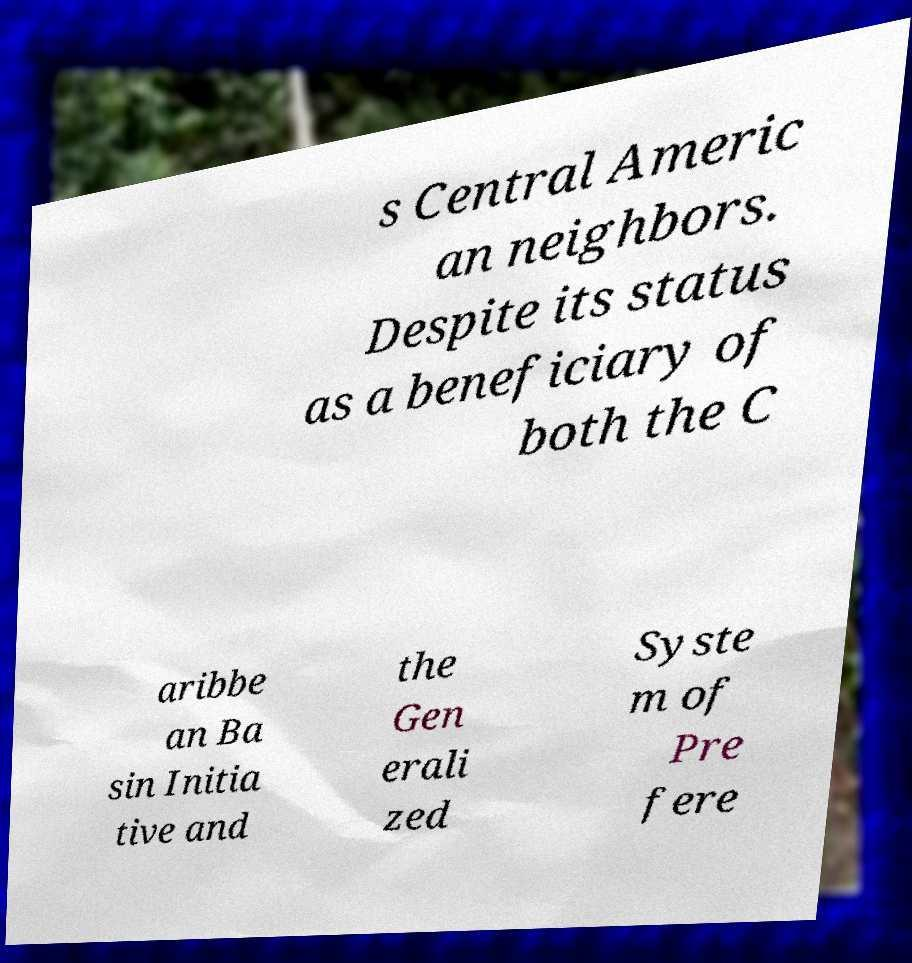Could you extract and type out the text from this image? s Central Americ an neighbors. Despite its status as a beneficiary of both the C aribbe an Ba sin Initia tive and the Gen erali zed Syste m of Pre fere 